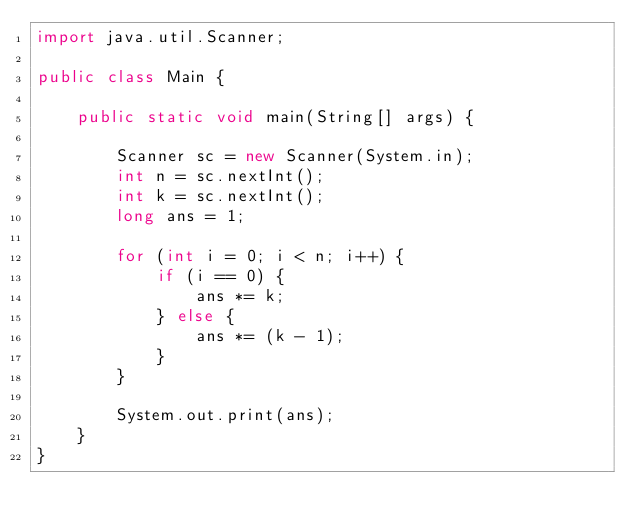<code> <loc_0><loc_0><loc_500><loc_500><_Java_>import java.util.Scanner;

public class Main {

	public static void main(String[] args) {

		Scanner sc = new Scanner(System.in);
		int n = sc.nextInt();
		int k = sc.nextInt();
		long ans = 1;

		for (int i = 0; i < n; i++) {
			if (i == 0) {
				ans *= k;
			} else {
				ans *= (k - 1);
			}
		}

		System.out.print(ans);
	}
}</code> 